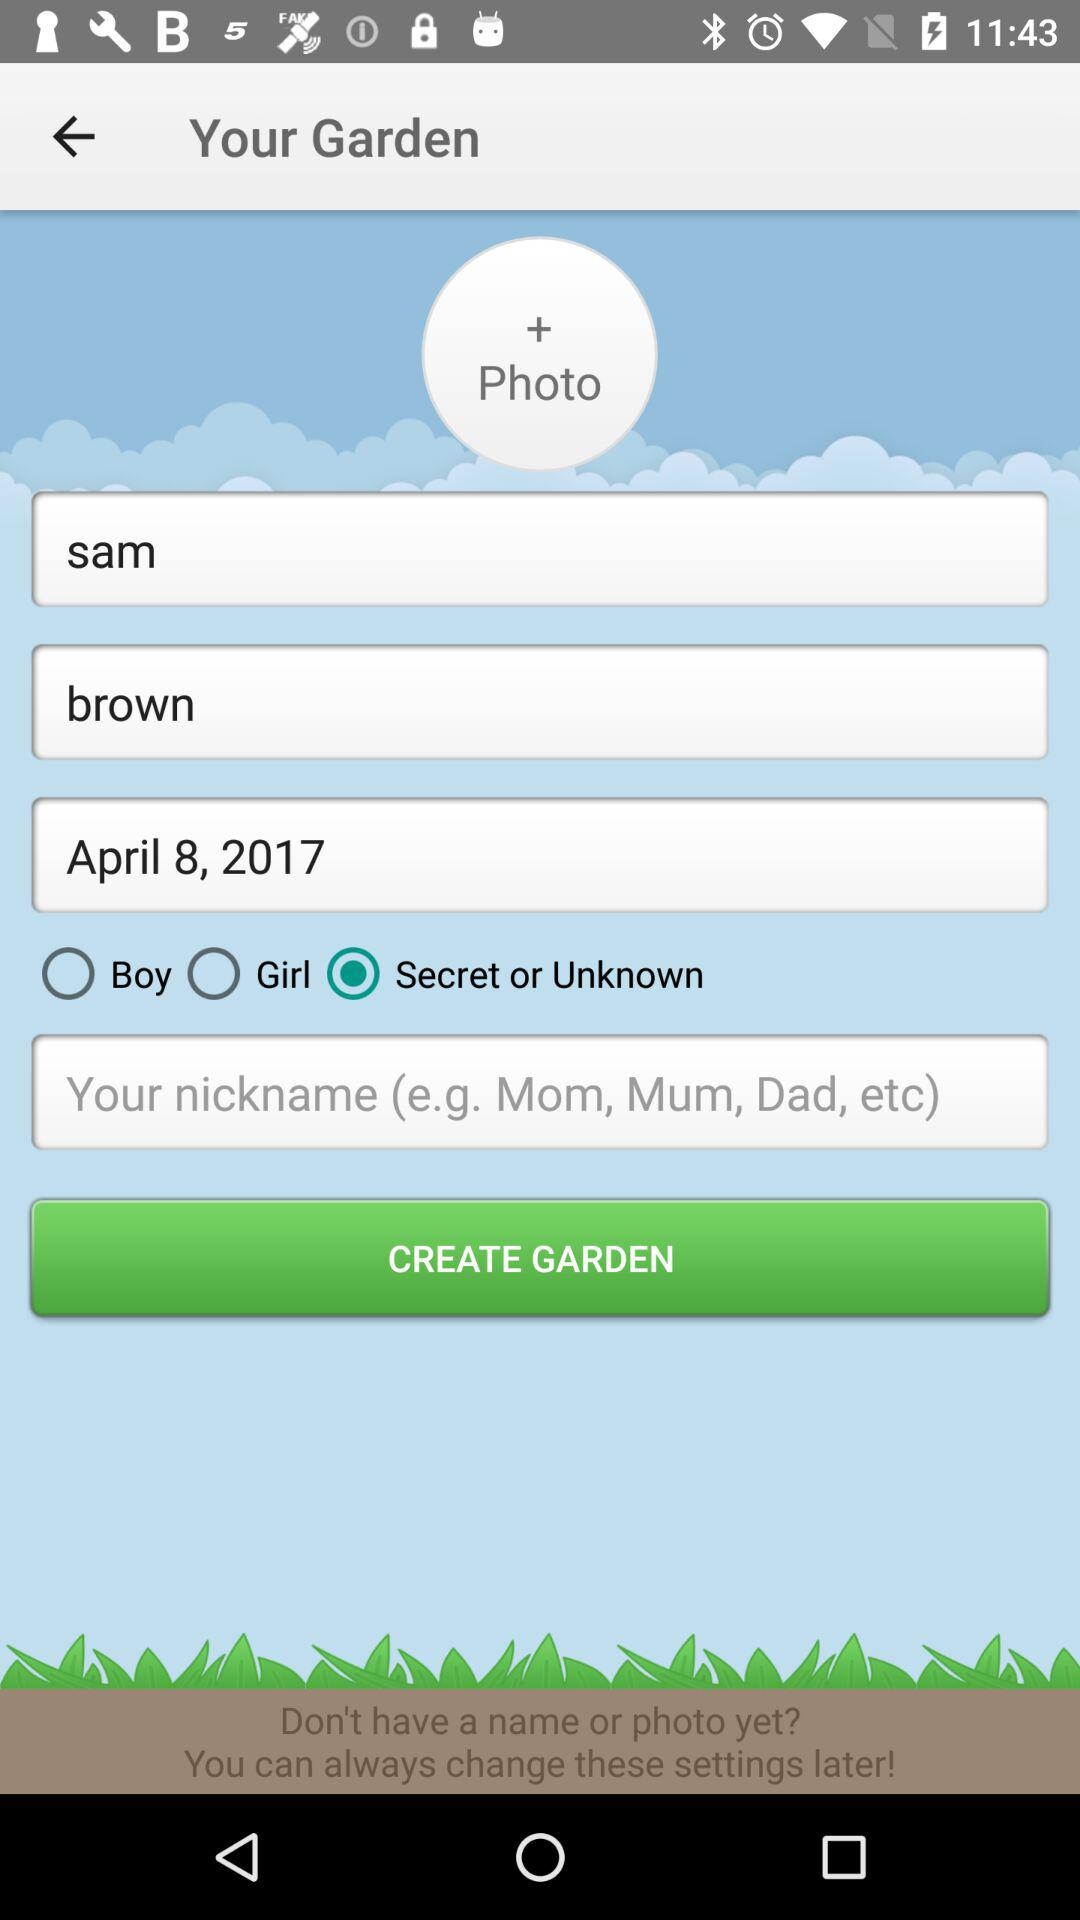What's the date? The date is April 8, 2017. 